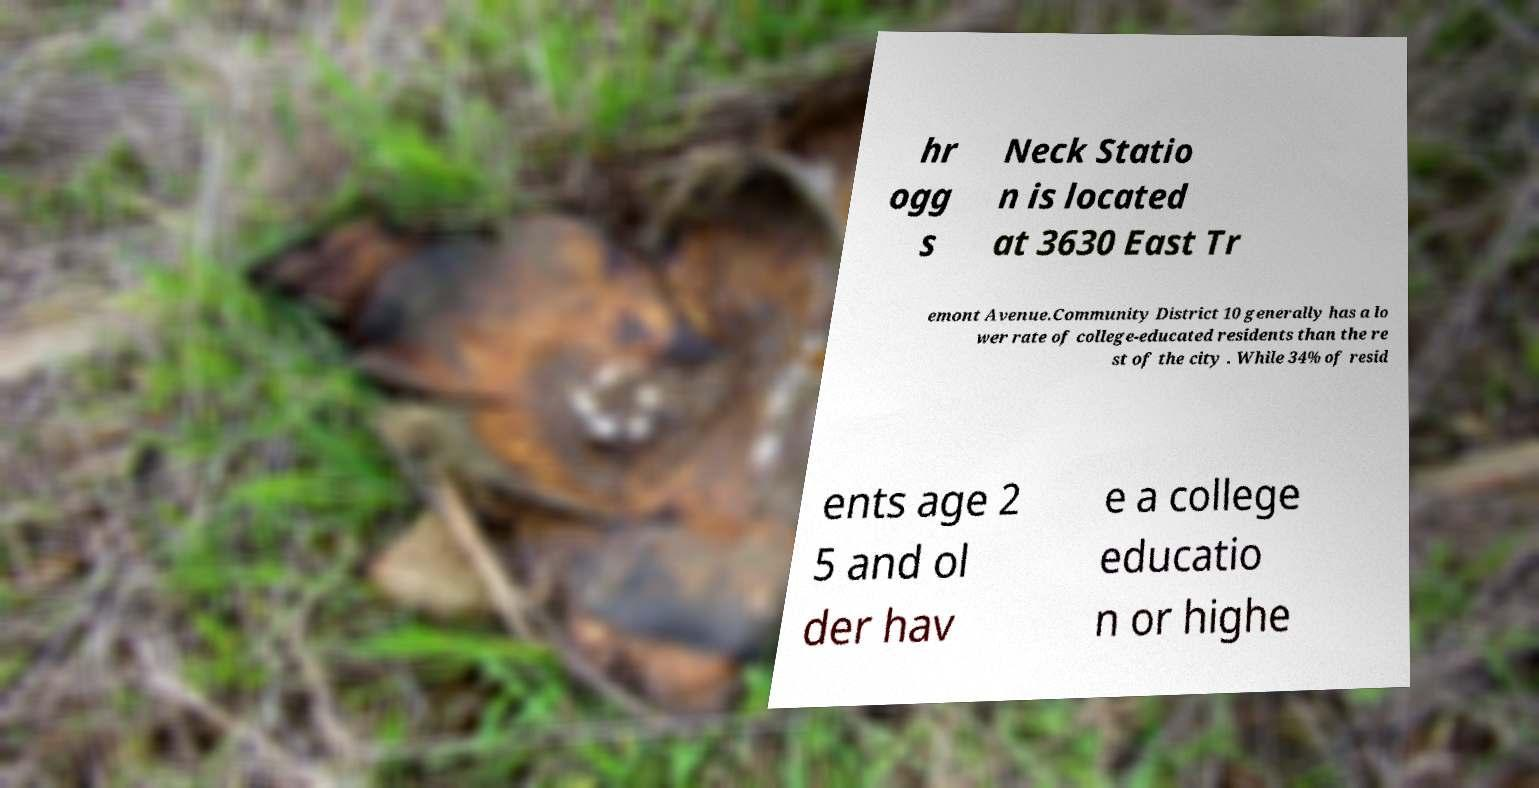There's text embedded in this image that I need extracted. Can you transcribe it verbatim? hr ogg s Neck Statio n is located at 3630 East Tr emont Avenue.Community District 10 generally has a lo wer rate of college-educated residents than the re st of the city . While 34% of resid ents age 2 5 and ol der hav e a college educatio n or highe 